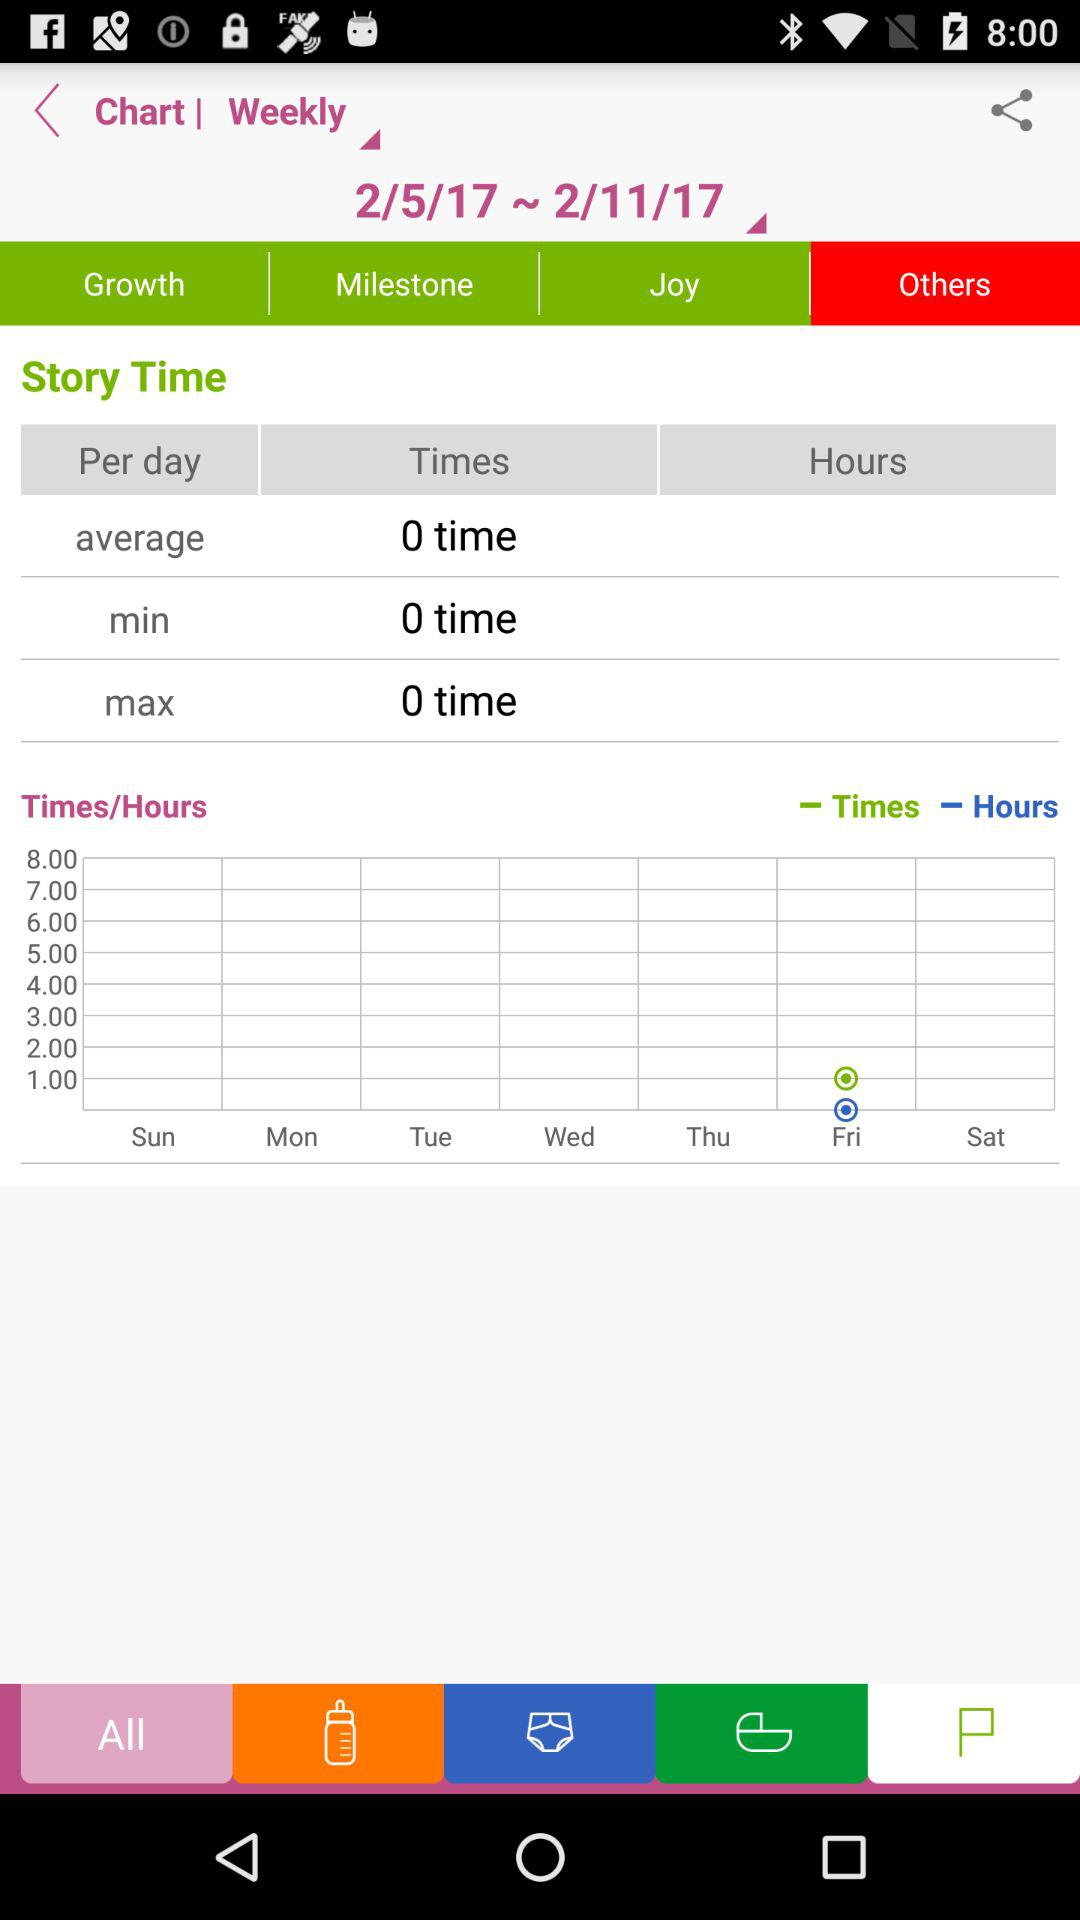Which date range is selected? The selected date range is from February 5, 2017 to February 11, 2017. 